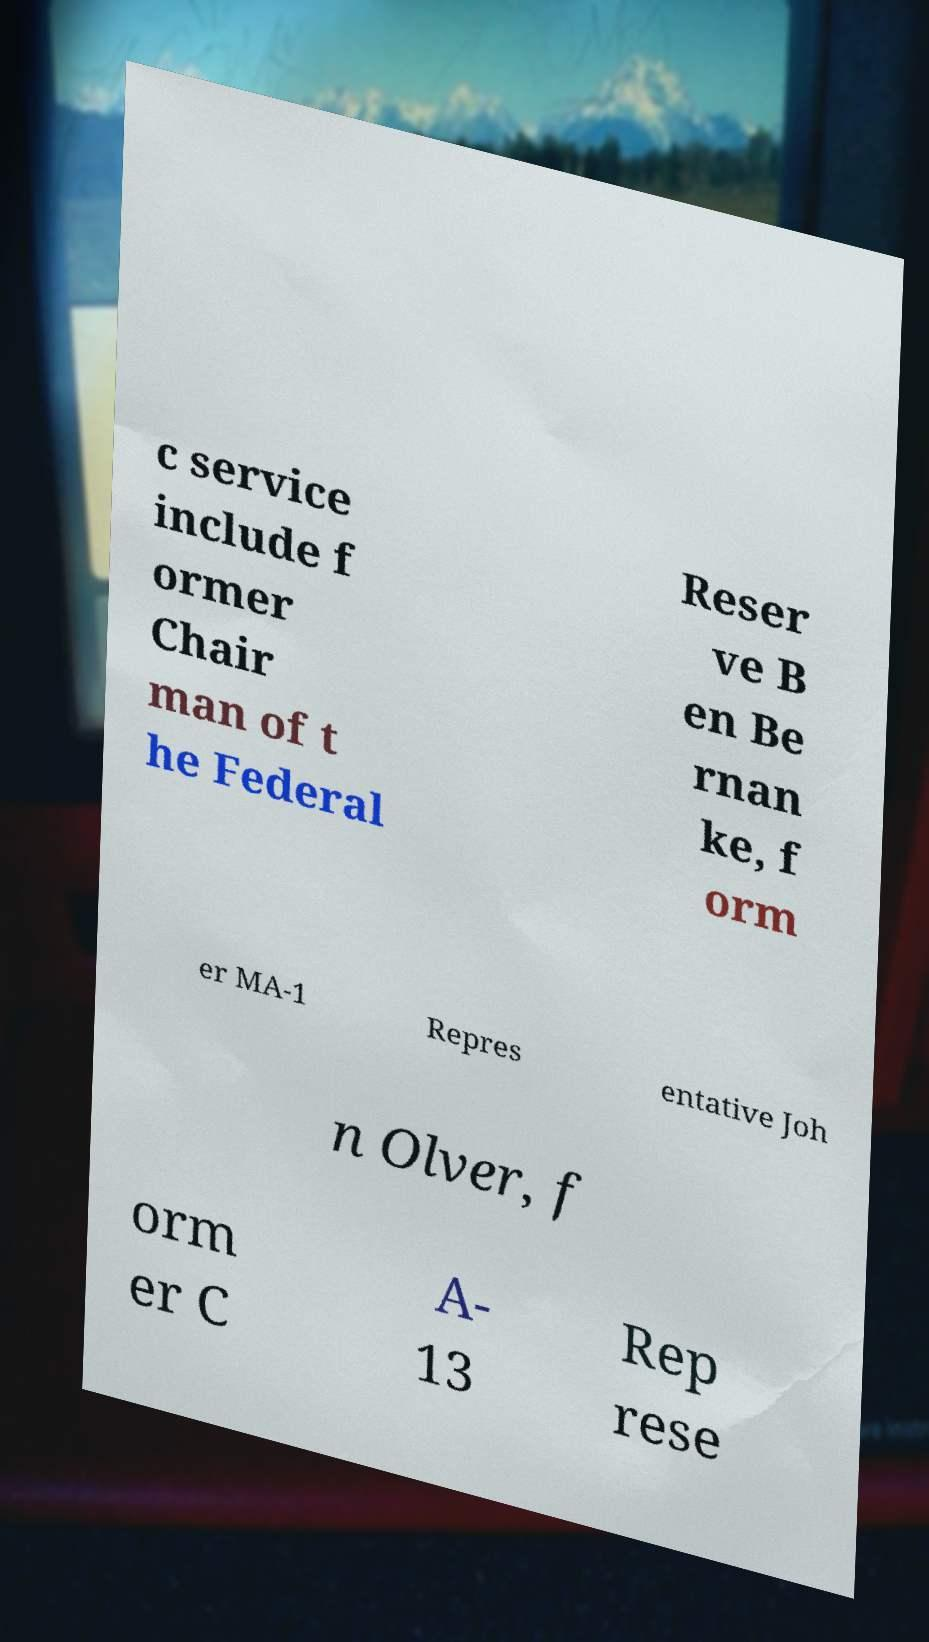Please identify and transcribe the text found in this image. c service include f ormer Chair man of t he Federal Reser ve B en Be rnan ke, f orm er MA-1 Repres entative Joh n Olver, f orm er C A- 13 Rep rese 